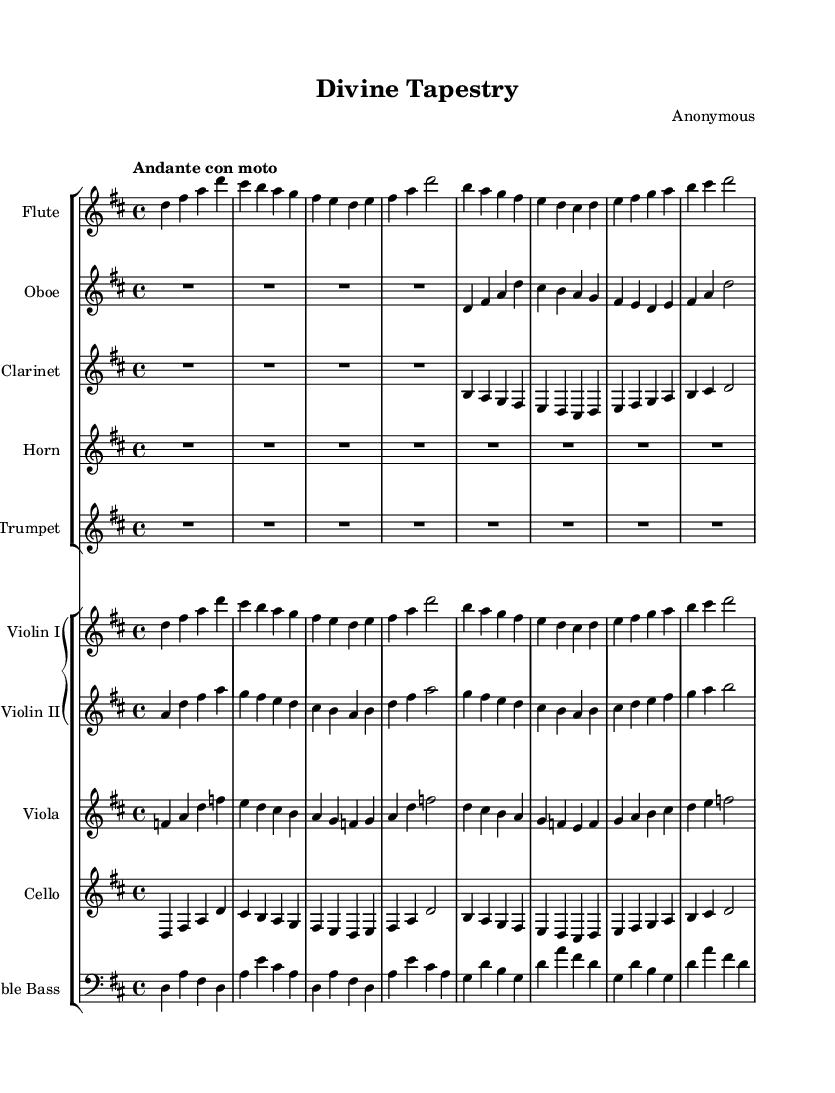What is the key signature of this music? The key signature is indicated at the beginning of the staff. There are two sharps shown, which correspond to F# and C#. This indicates the piece is in D major.
Answer: D major What is the time signature of this music? The time signature is located at the beginning of the staff, where it shows "4/4". This indicates there are four beats in a measure and the quarter note gets one beat.
Answer: 4/4 What is the tempo marking of this piece? The tempo marking at the beginning states "Andante con moto", suggesting a moderate pace with a slight forward motion.
Answer: Andante con moto How many measures are there in the flute part? By counting the vertical lines that represent measures in the flute staff, we find a total of 8 measures present.
Answer: 8 Which instruments have a transposition indicated? By examining the indicated transposition in the parts, it is clear that both the clarinet and horn have transposition indicated, showing their respective transpositions to B-flat and F.
Answer: Clarinet and horn How many notes are in the first measure of the violin I part? The first measure of the violin I part contains four notes: D, F#, A, and D. Counting these gives us a total of four notes in that measure.
Answer: 4 What is the highest note in the entire score? By analyzing the score, we can identify that the highest note is A, which appears in various parts, including the flute and the violin I part, as indicated by the note placements.
Answer: A 